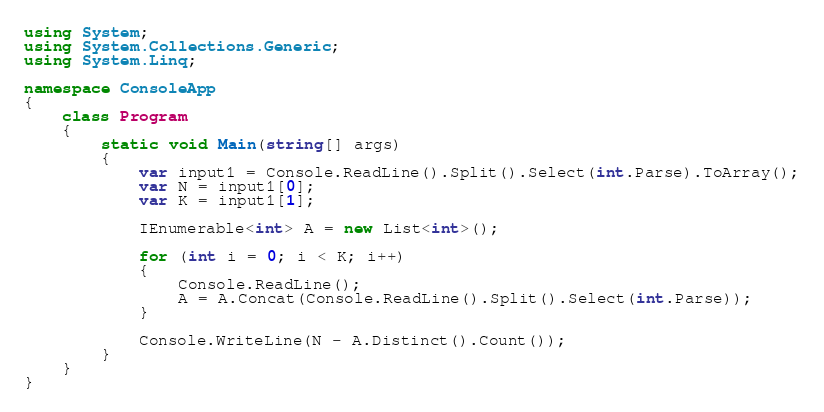Convert code to text. <code><loc_0><loc_0><loc_500><loc_500><_C#_>using System;
using System.Collections.Generic;
using System.Linq;

namespace ConsoleApp
{
    class Program
    {
        static void Main(string[] args)
        {
            var input1 = Console.ReadLine().Split().Select(int.Parse).ToArray();
            var N = input1[0];
            var K = input1[1];

            IEnumerable<int> A = new List<int>();

            for (int i = 0; i < K; i++)
            {
                Console.ReadLine();
                A = A.Concat(Console.ReadLine().Split().Select(int.Parse));
            }

            Console.WriteLine(N - A.Distinct().Count());
        }
    }
}
</code> 